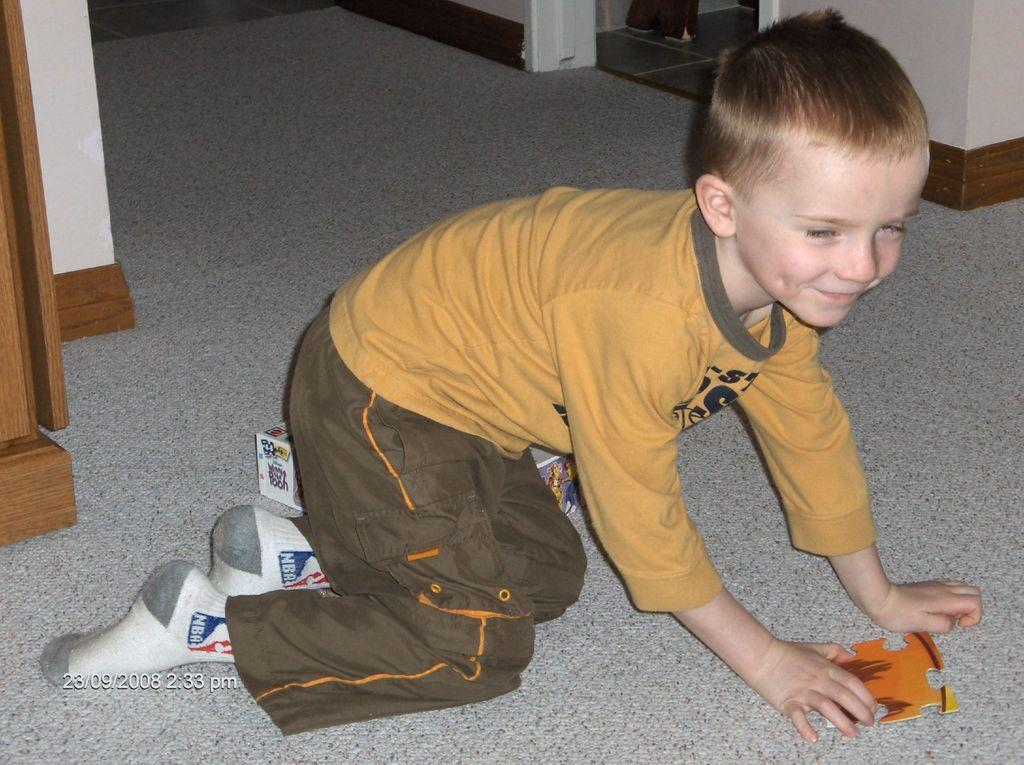What is the main subject of the image? There is a child in the image. What is the child holding in the image? The child is holding a piece of puzzle. What can be seen on the floor in the image? There is a cardboard box on the floor in the image. What is visible in the background of the image? There is a wall in the image. Can you tell me how many giraffes are in the image? There are no giraffes present in the image. What type of lock is used to secure the puzzle in the image? There is no lock present in the image, as the child is holding a piece of puzzle. 